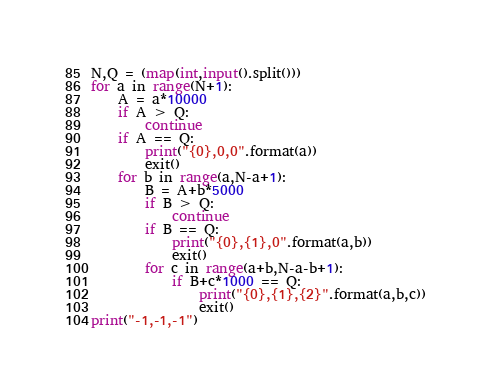<code> <loc_0><loc_0><loc_500><loc_500><_Python_>N,Q = (map(int,input().split()))
for a in range(N+1):
    A = a*10000
    if A > Q:
        continue
    if A == Q:
        print("{0},0,0".format(a))
        exit()
    for b in range(a,N-a+1):
        B = A+b*5000
        if B > Q:
            continue
        if B == Q:
            print("{0},{1},0".format(a,b))
            exit()
        for c in range(a+b,N-a-b+1):
            if B+c*1000 == Q:
                print("{0},{1},{2}".format(a,b,c))
                exit()
print("-1,-1,-1")</code> 